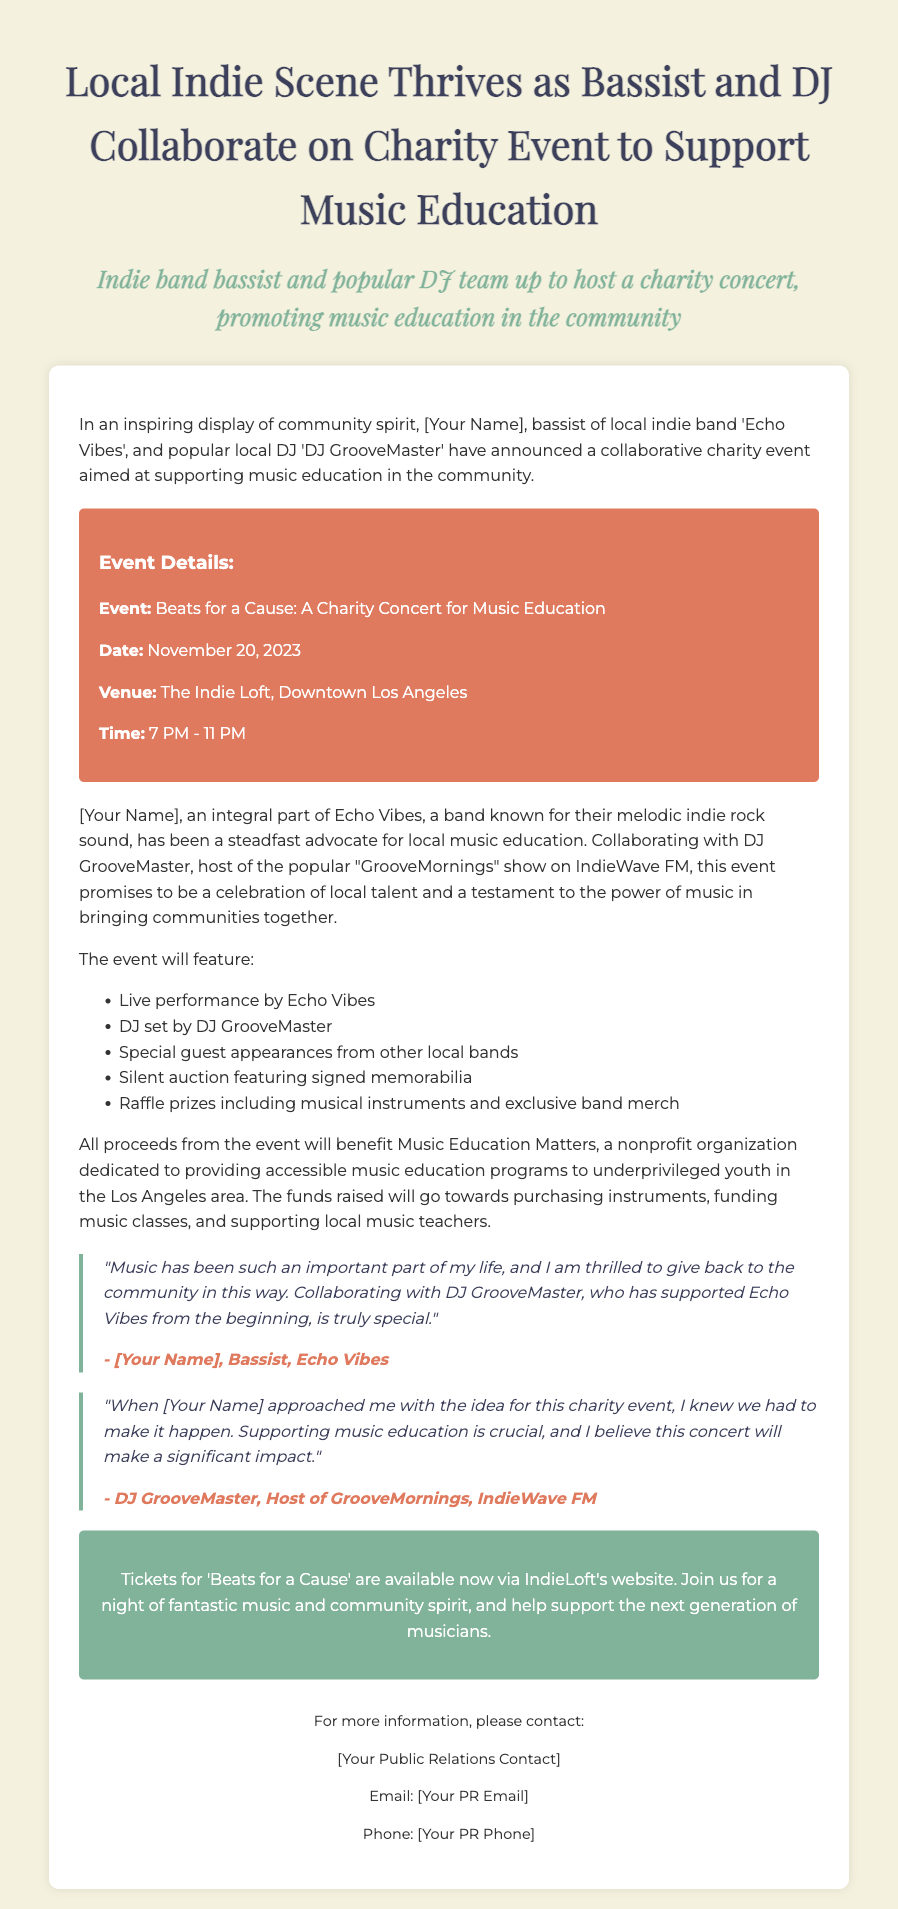What is the name of the charity event? The name of the charity event is mentioned in the event details section of the document.
Answer: Beats for a Cause: A Charity Concert for Music Education Who are the main organizers of the event? The document mentions the key individuals collaborating for the event.
Answer: [Your Name] and DJ GrooveMaster What date is the charity event scheduled for? The date of the event is clearly stated in the event details section.
Answer: November 20, 2023 What venue will host the charity concert? The venue for the event is specified in the event details section of the document.
Answer: The Indie Loft, Downtown Los Angeles What is the purpose of the event? The purpose of the event is described in the opening paragraph and further elaborated in subsequent sections.
Answer: Supporting music education How will the proceeds from the event be used? The document explains the allocation of funds raised at the event.
Answer: To benefit Music Education Matters What can attendees expect during the event? The document provides a list of activities and features at the event.
Answer: Live performance, DJ set, special guest appearances, silent auction, raffle prizes What does the quote from [Your Name] express? The quote highlights the personal feelings and motivations of [Your Name] regarding the event.
Answer: Thrill to give back to the community Who hosts the show that DJ GrooveMaster is associated with? The document references the show that DJ GrooveMaster hosts as part of his role.
Answer: GrooveMornings What type of items will be available in the silent auction? The document mentions specific items that will be featured in the auction.
Answer: Signed memorabilia 